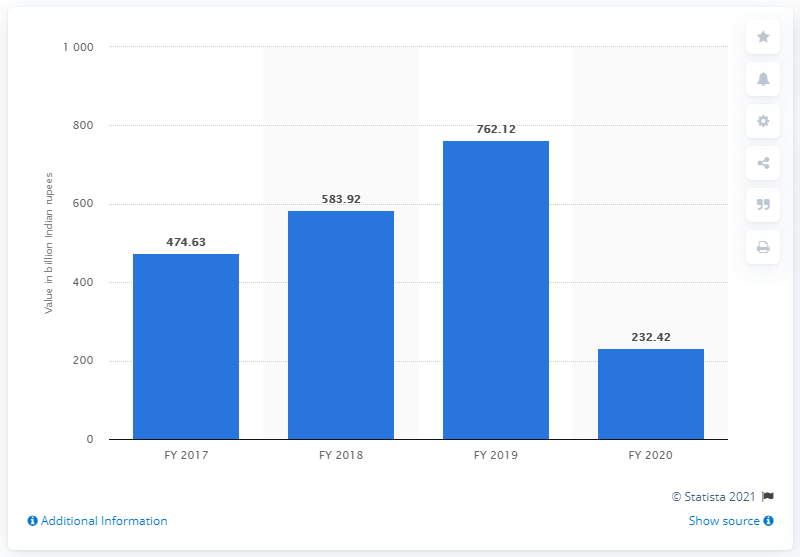Point out several critical features in this image. Reliance Jio reported a total debt of 232.42 in the fiscal year 2020. 